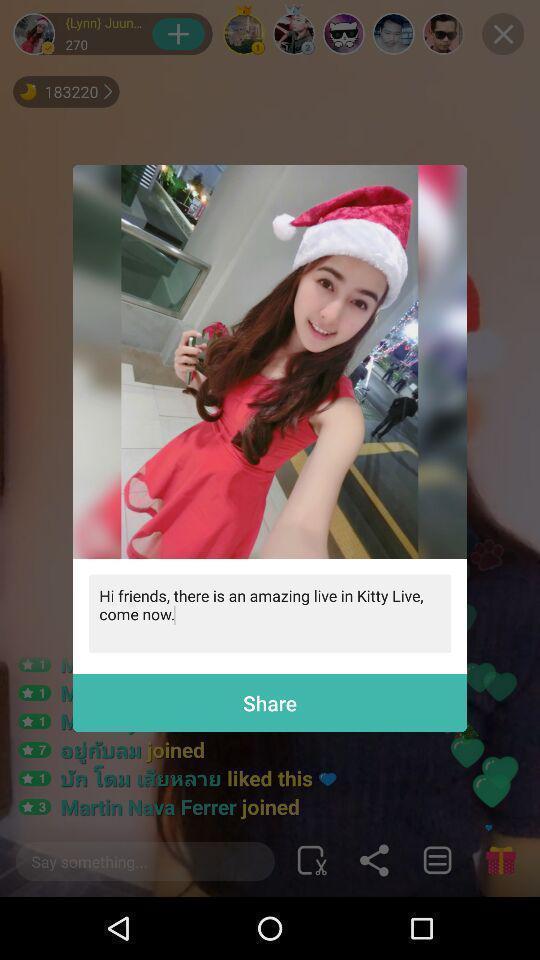Describe the content in this image. Popup showing picture text and share option in entertainment app. 